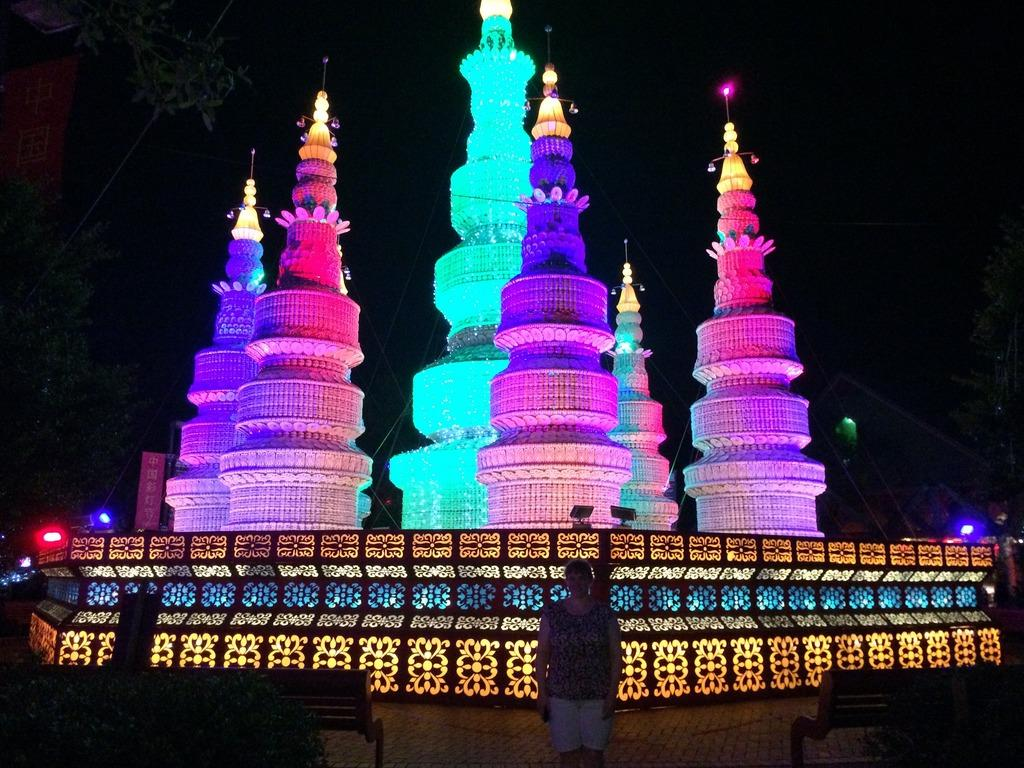What is the main subject of the image? There is a person standing in the image. What is located on either side of the person? There are two benches on either side of the person. What can be seen in the background of the image? There are objects decorated with lights in the background of the image. What type of plantation can be seen in the background of the image? There is no plantation present in the image; the background features objects decorated with lights. 